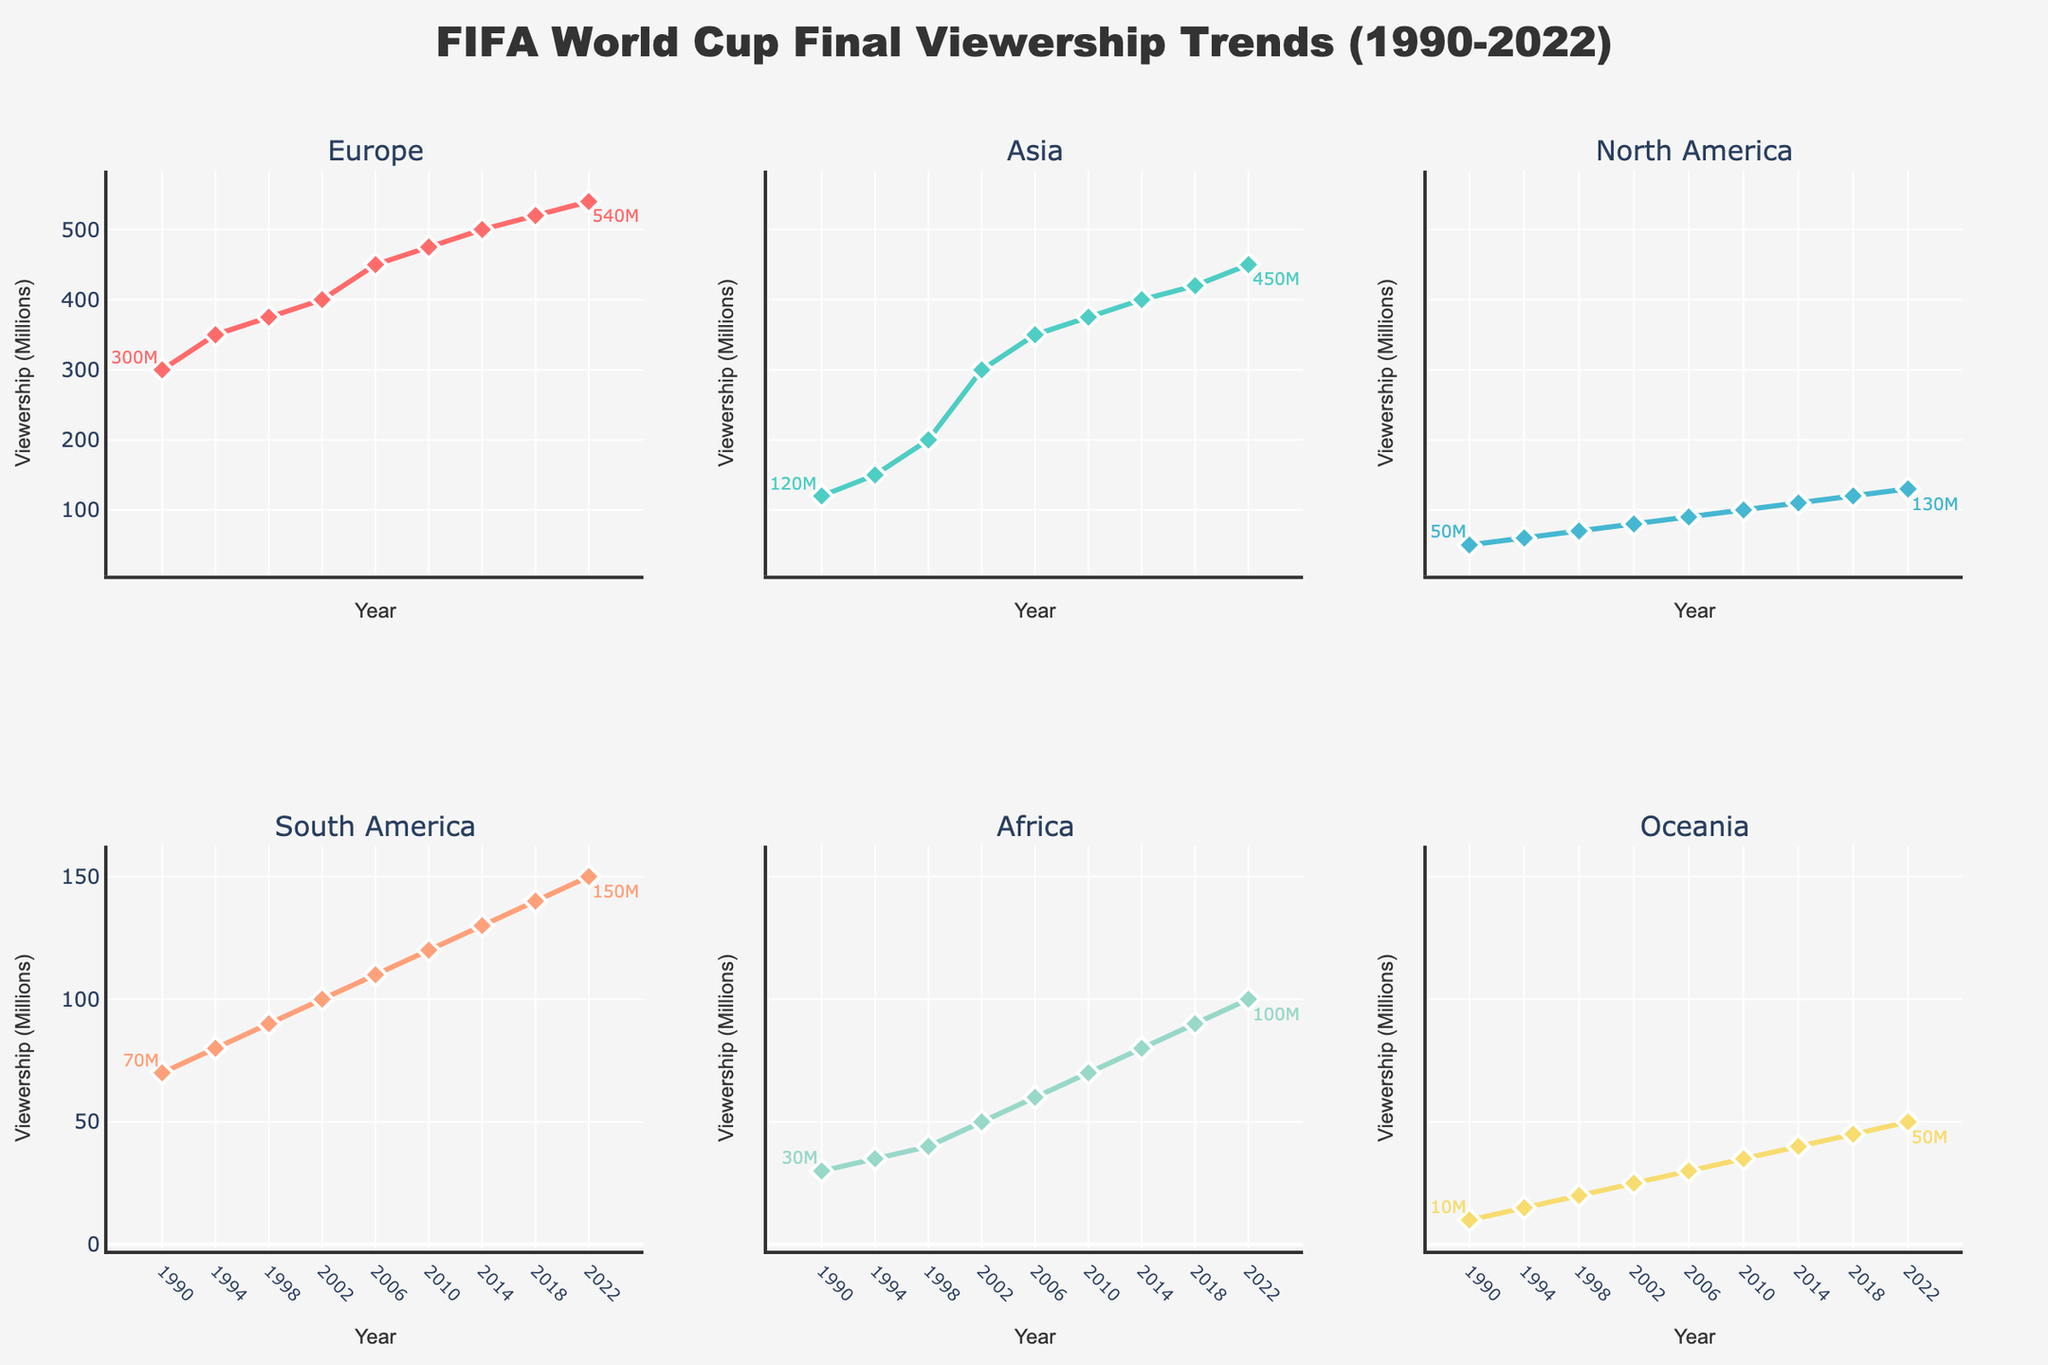How many total regions are represented in the figure? The figure has subplots for different regions. By counting the subplot titles, we determine that there are 6 regions represented.
Answer: 6 What is the title of the figure? The figure's title is located at the top center of the plot. It reads "FIFA World Cup Final Viewership Trends (1990-2022)."
Answer: FIFA World Cup Final Viewership Trends (1990-2022) What is the general trend in viewership for Europe from 1990 to 2022? Observing the time series plot for Europe, viewership shows an overall increasing trend from 300 million in 1990 to 540 million in 2022.
Answer: Increasing Which region had the lowest viewership in 1990, and what was the value? By checking the viewership values for each region in 1990, Oceania has the lowest viewership at 10 million.
Answer: Oceania, 10 million Which region experienced the highest increase in viewership from 1990 to 2022? Comparing the starting and ending viewership values for each region, Asia increased from 120 million to 450 million, which is the highest increase of 330 million.
Answer: Asia Between 2018 and 2022, which region saw the largest absolute increase in viewership? By calculating the difference in viewership between 2018 and 2022 for each region, Asia had the largest increase from 420 million to 450 million (30 million increase).
Answer: Asia What was the viewership in South America in 2014? Refer to the plot for South America and locate the data point for the year 2014, which shows the viewership at 130 million.
Answer: 130 million How does the 1994 viewership in Africa compare to that in 1990? Checking the plot, Africa's viewership in 1990 was 30 million, and in 1994 it was 35 million, showing an increase of 5 million.
Answer: Increased by 5 million Which region had the closest viewership values between 1994 and 1998? By comparing the values side-by-side for each region, Oceania had the closest values with 15 million in 1994 and 20 million in 1998 (difference of 5 million).
Answer: Oceania 